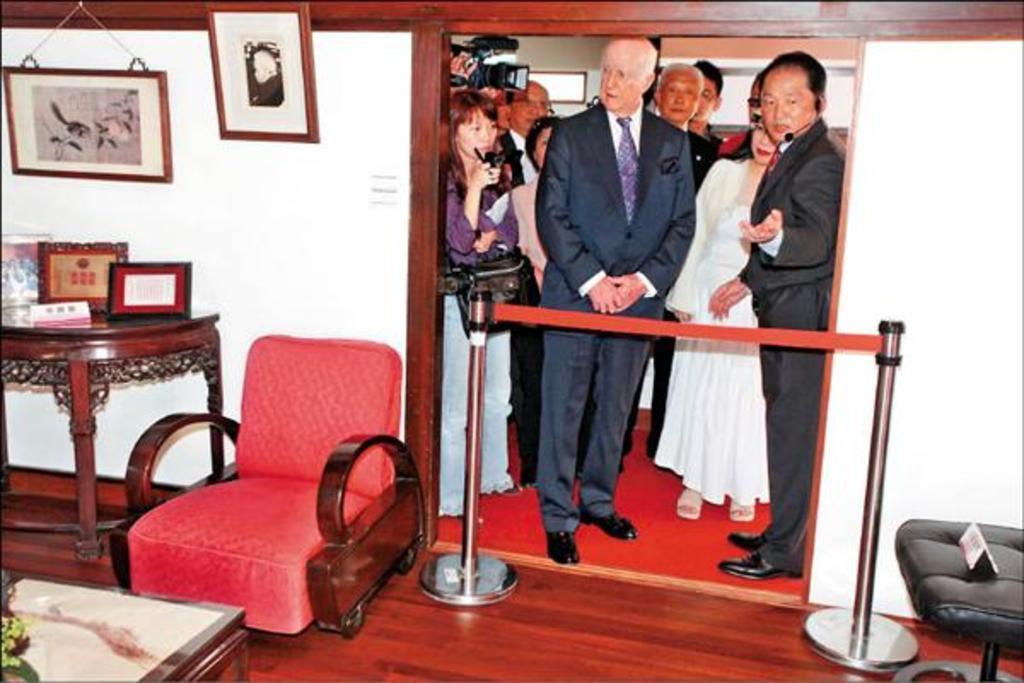How would you summarize this image in a sentence or two? There are many people standing. In the front there is a man wearing jacket and standing. A lady with white frock. And some are holding video camera in their hands. There is a pink color chair. On the table some frames. On the wall there are some two frames. 